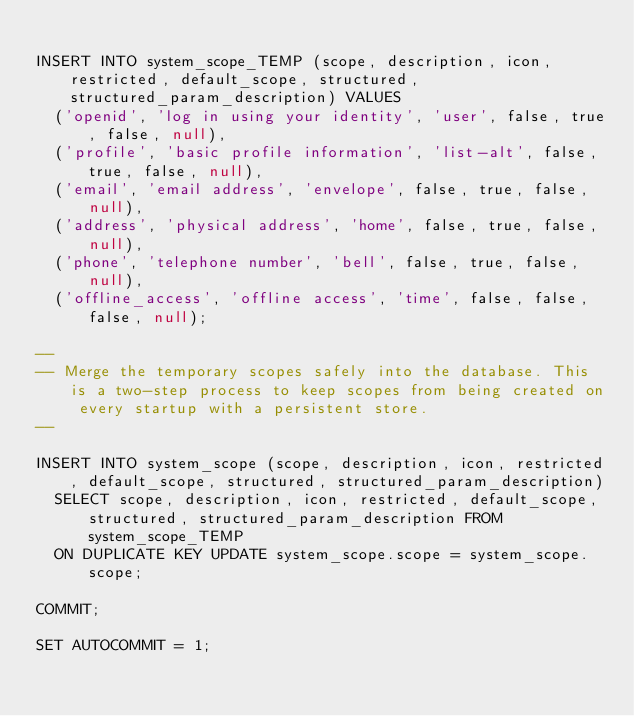Convert code to text. <code><loc_0><loc_0><loc_500><loc_500><_SQL_>
INSERT INTO system_scope_TEMP (scope, description, icon, restricted, default_scope, structured, structured_param_description) VALUES
  ('openid', 'log in using your identity', 'user', false, true, false, null),
  ('profile', 'basic profile information', 'list-alt', false, true, false, null),
  ('email', 'email address', 'envelope', false, true, false, null),
  ('address', 'physical address', 'home', false, true, false, null),
  ('phone', 'telephone number', 'bell', false, true, false, null),
  ('offline_access', 'offline access', 'time', false, false, false, null);
  
--
-- Merge the temporary scopes safely into the database. This is a two-step process to keep scopes from being created on every startup with a persistent store.
--

INSERT INTO system_scope (scope, description, icon, restricted, default_scope, structured, structured_param_description) 
  SELECT scope, description, icon, restricted, default_scope, structured, structured_param_description FROM system_scope_TEMP
  ON DUPLICATE KEY UPDATE system_scope.scope = system_scope.scope;

COMMIT;

SET AUTOCOMMIT = 1;</code> 